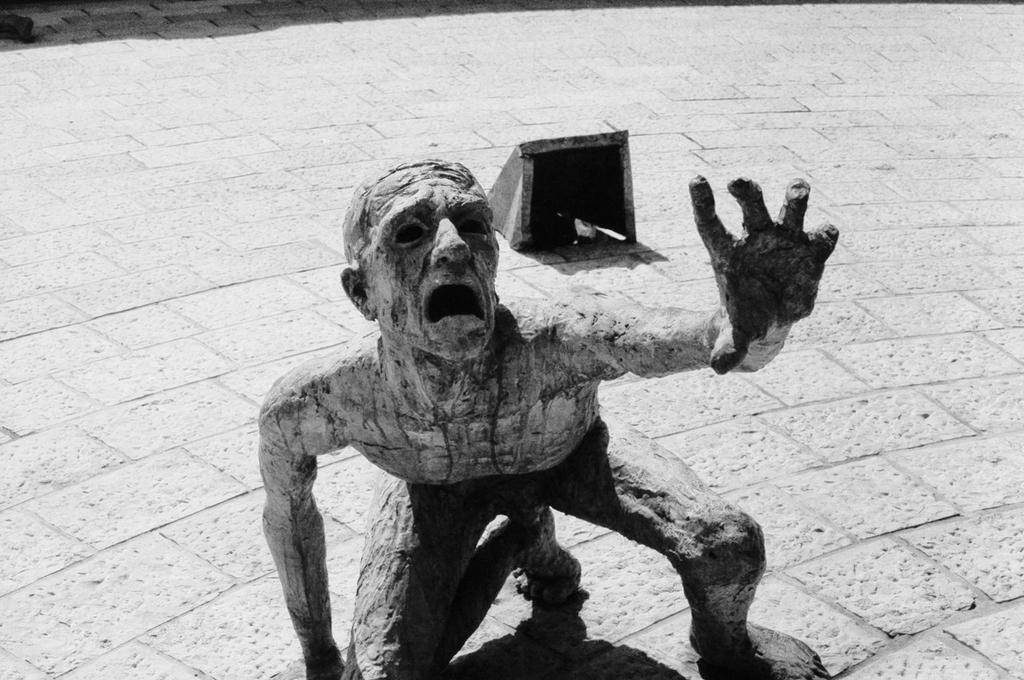What is the main subject of the image? There is a statue of a man in the image. Where is the statue located? The statue is on the ground. What other object can be seen on the floor in the image? There is a light with a cover on the floor in the image. What type of door can be seen in the image? There is no door present in the image; it features a statue of a man and a light with a cover on the floor. 